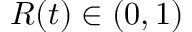Convert formula to latex. <formula><loc_0><loc_0><loc_500><loc_500>R ( t ) \in ( 0 , 1 )</formula> 